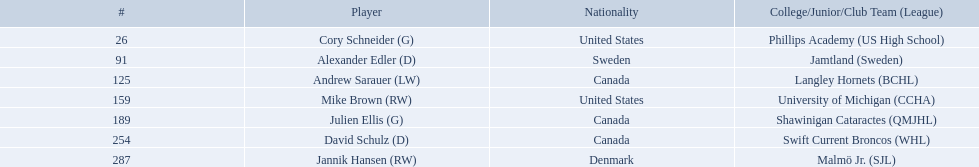What are the nationalities of the players? United States, Sweden, Canada, United States, Canada, Canada, Denmark. Of the players, which one lists his nationality as denmark? Jannik Hansen (RW). Who are the players? Cory Schneider (G), Alexander Edler (D), Andrew Sarauer (LW), Mike Brown (RW), Julien Ellis (G), David Schulz (D), Jannik Hansen (RW). Of those, who is from denmark? Jannik Hansen (RW). Who were the players in the 2004-05 vancouver canucks season Cory Schneider (G), Alexander Edler (D), Andrew Sarauer (LW), Mike Brown (RW), Julien Ellis (G), David Schulz (D), Jannik Hansen (RW). Of these players who had a nationality of denmark? Jannik Hansen (RW). What are the names of the colleges and jr leagues the players attended? Phillips Academy (US High School), Jamtland (Sweden), Langley Hornets (BCHL), University of Michigan (CCHA), Shawinigan Cataractes (QMJHL), Swift Current Broncos (WHL), Malmö Jr. (SJL). Which player played for the langley hornets? Andrew Sarauer (LW). Who are all the players? Cory Schneider (G), Alexander Edler (D), Andrew Sarauer (LW), Mike Brown (RW), Julien Ellis (G), David Schulz (D), Jannik Hansen (RW). What is the nationality of each player? United States, Sweden, Canada, United States, Canada, Canada, Denmark. Where did they attend school? Phillips Academy (US High School), Jamtland (Sweden), Langley Hornets (BCHL), University of Michigan (CCHA), Shawinigan Cataractes (QMJHL), Swift Current Broncos (WHL), Malmö Jr. (SJL). Which player attended langley hornets? Andrew Sarauer (LW). 